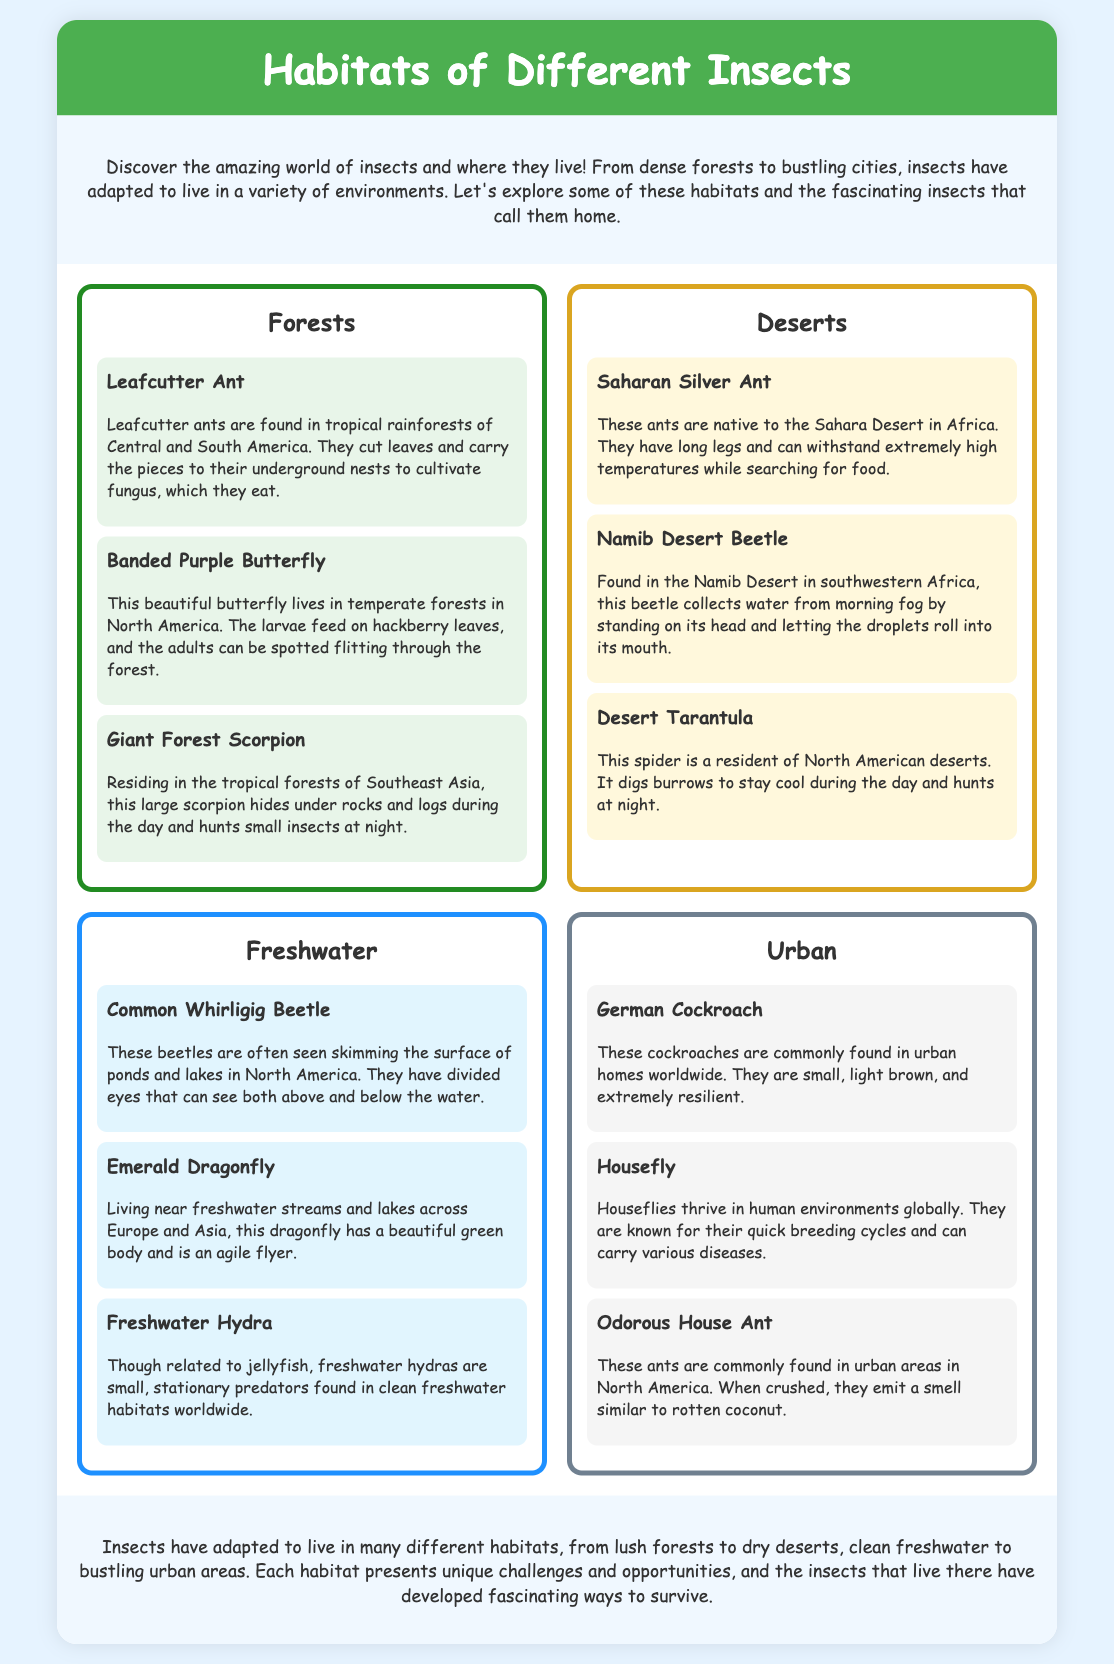What is the title of the document? The title is prominently displayed at the top of the document and indicates the main subject it covers.
Answer: Habitats of Different Insects How many habitats are listed in the infographic? The infographic categorizes insects into four distinct habitats, as shown in the document.
Answer: Four What insect lives in freshwater habitats? The document lists several insects under the freshwater category, specifically mentioning one as an example.
Answer: Common Whirligig Beetle Which insect is described as having a smell like rotten coconut? The document provides a specific detail about one ant found in urban areas, focusing on the unique smell it emits when crushed.
Answer: Odorous House Ant In which habitat can the Giant Forest Scorpion be found? This question refers to the location details provided for the Giant Forest Scorpion in the forest category.
Answer: Forests What activity do Leafcutter Ants engage in? The document describes the actions of Leafcutter Ants and highlights their unique behavior concerning leaves.
Answer: Cultivate fungus Which desert insect collects water from morning fog? Information in the desert section mentions a specific insect behavior related to gathering water in harsh environments.
Answer: Namib Desert Beetle What color is the background of the document? The overall design of the document includes an aesthetic use of color that serves as a backdrop for all content.
Answer: Light blue 